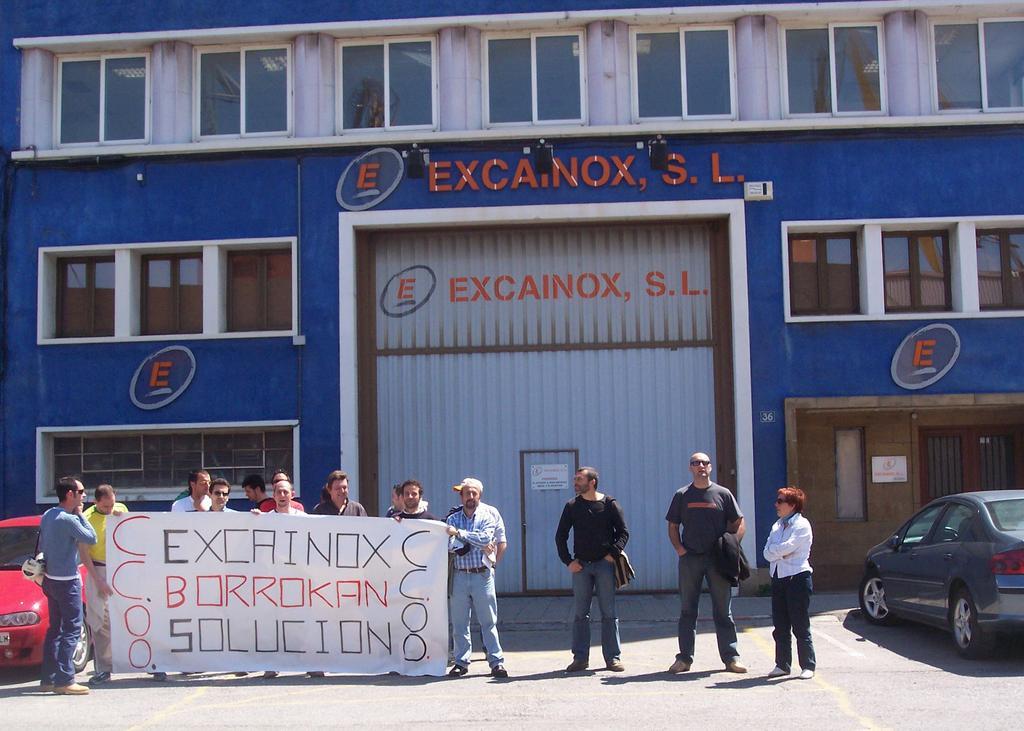In one or two sentences, can you explain what this image depicts? In this image I can see few persons standing on the ground and holding a banner which is white in color in their hands and in the background I can see few cars which are red and black in color, a building which is blue and white in color and few windows of the building. 